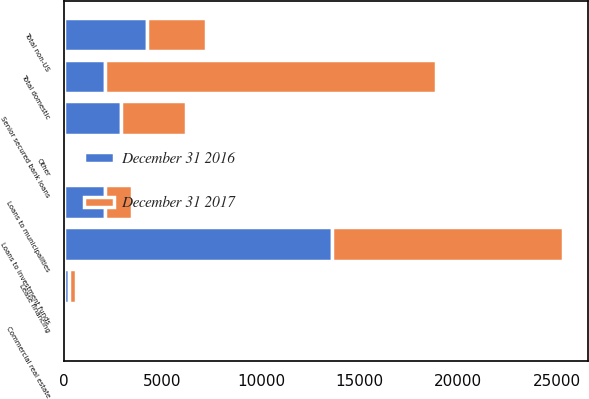Convert chart to OTSL. <chart><loc_0><loc_0><loc_500><loc_500><stacked_bar_chart><ecel><fcel>Loans to investment funds<fcel>Senior secured bank loans<fcel>Loans to municipalities<fcel>Other<fcel>Commercial real estate<fcel>Lease financing<fcel>Total domestic<fcel>Total non-US<nl><fcel>December 31 2016<fcel>13618<fcel>2923<fcel>2105<fcel>50<fcel>98<fcel>267<fcel>2105<fcel>4233<nl><fcel>December 31 2017<fcel>11734<fcel>3256<fcel>1352<fcel>70<fcel>27<fcel>338<fcel>16777<fcel>2980<nl></chart> 